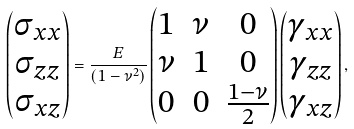<formula> <loc_0><loc_0><loc_500><loc_500>\begin{pmatrix} \sigma _ { x x } \\ \sigma _ { z z } \\ \sigma _ { x z } \end{pmatrix} = \frac { E } { ( 1 - \nu ^ { 2 } ) } \begin{pmatrix} 1 & \nu & 0 \\ \nu & 1 & 0 \\ 0 & 0 & \frac { 1 - \nu } { 2 } \end{pmatrix} \begin{pmatrix} \gamma _ { x x } \\ \gamma _ { z z } \\ \gamma _ { x z } \end{pmatrix} ,</formula> 